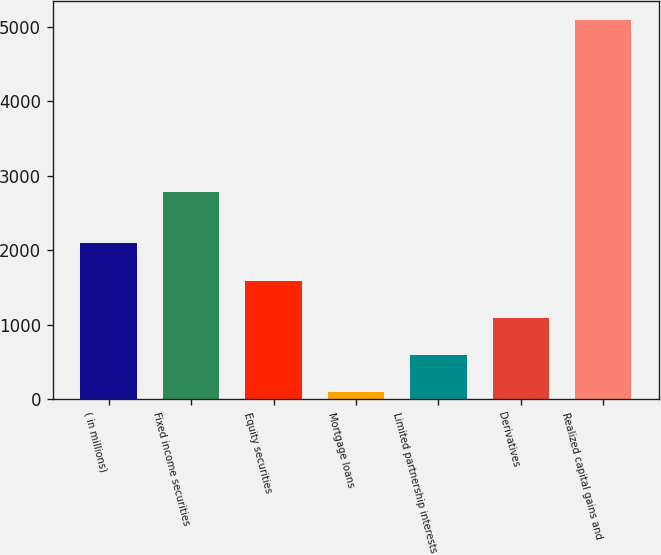<chart> <loc_0><loc_0><loc_500><loc_500><bar_chart><fcel>( in millions)<fcel>Fixed income securities<fcel>Equity securities<fcel>Mortgage loans<fcel>Limited partnership interests<fcel>Derivatives<fcel>Realized capital gains and<nl><fcel>2092.4<fcel>2781<fcel>1592.8<fcel>94<fcel>593.6<fcel>1093.2<fcel>5090<nl></chart> 